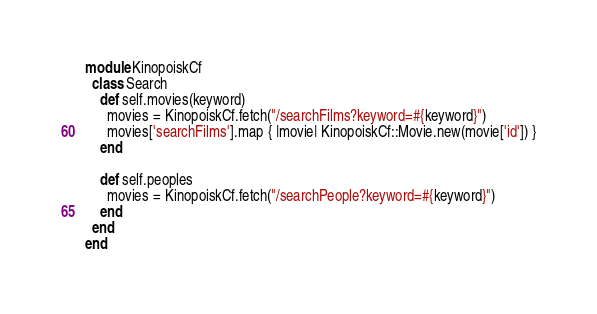Convert code to text. <code><loc_0><loc_0><loc_500><loc_500><_Ruby_>module KinopoiskCf
  class Search
    def self.movies(keyword)
      movies = KinopoiskCf.fetch("/searchFilms?keyword=#{keyword}")
      movies['searchFilms'].map { |movie| KinopoiskCf::Movie.new(movie['id']) }
    end

    def self.peoples
      movies = KinopoiskCf.fetch("/searchPeople?keyword=#{keyword}")
    end
  end
end
</code> 